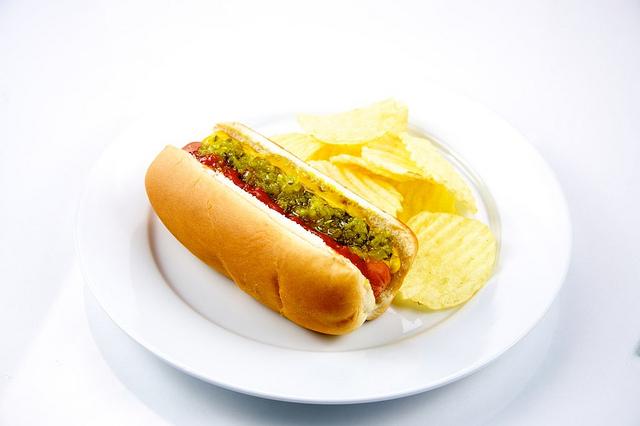Is this a good picnic food?
Be succinct. Yes. Do the potatoes on the plate have ridges?
Answer briefly. Yes. Does this meal look appetizing?
Concise answer only. Yes. 